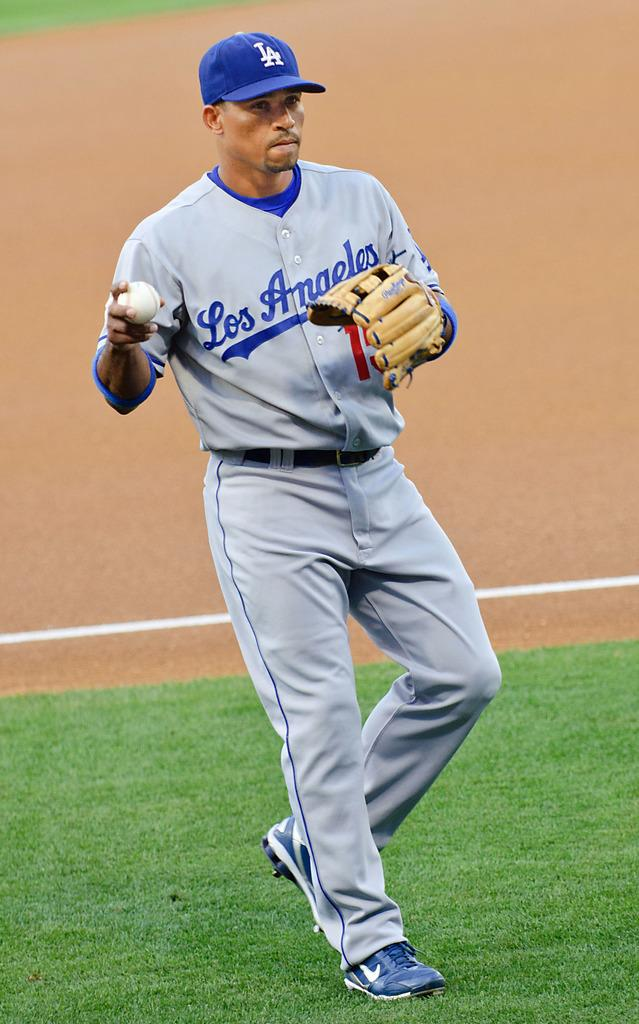<image>
Render a clear and concise summary of the photo. A baseball player is holding the ball and his uniform says Los Angeles. 